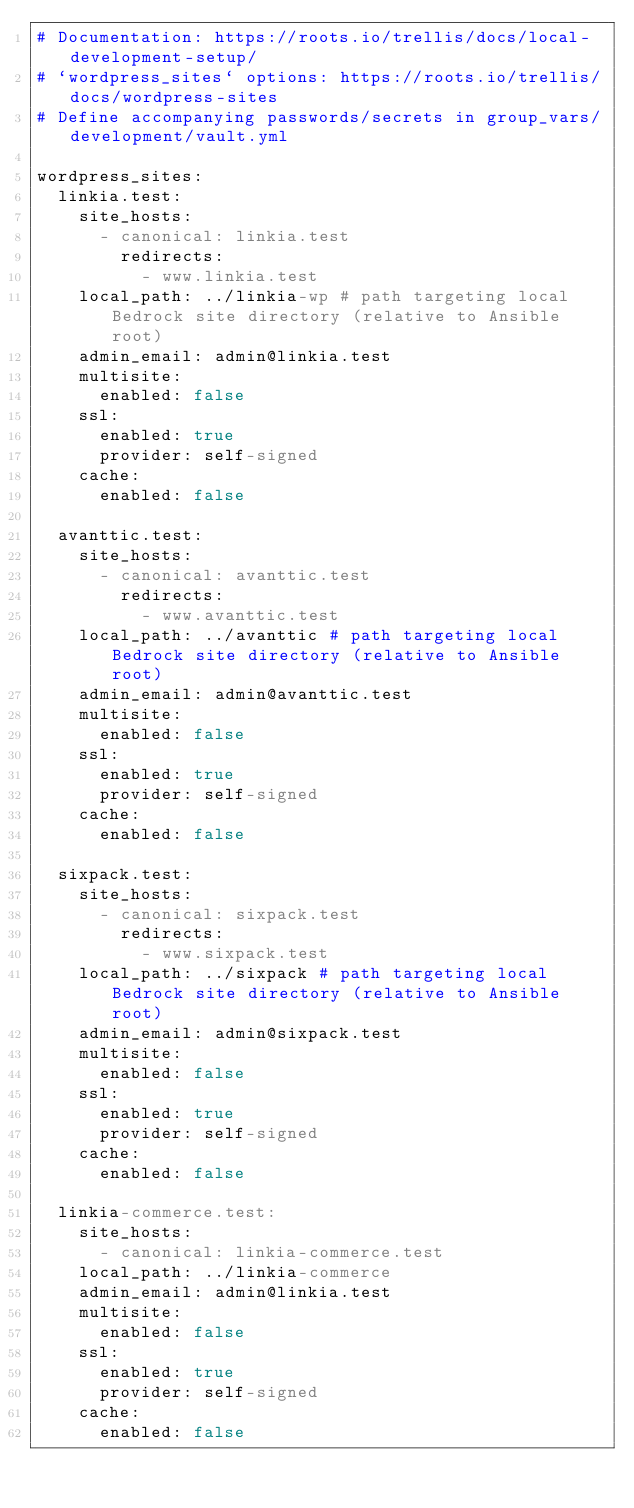Convert code to text. <code><loc_0><loc_0><loc_500><loc_500><_YAML_># Documentation: https://roots.io/trellis/docs/local-development-setup/
# `wordpress_sites` options: https://roots.io/trellis/docs/wordpress-sites
# Define accompanying passwords/secrets in group_vars/development/vault.yml

wordpress_sites:
  linkia.test:
    site_hosts:
      - canonical: linkia.test
        redirects:
          - www.linkia.test
    local_path: ../linkia-wp # path targeting local Bedrock site directory (relative to Ansible root)
    admin_email: admin@linkia.test
    multisite:
      enabled: false
    ssl:
      enabled: true
      provider: self-signed
    cache:
      enabled: false

  avanttic.test:
    site_hosts:
      - canonical: avanttic.test
        redirects:
          - www.avanttic.test
    local_path: ../avanttic # path targeting local Bedrock site directory (relative to Ansible root)
    admin_email: admin@avanttic.test
    multisite:
      enabled: false
    ssl:
      enabled: true
      provider: self-signed
    cache:
      enabled: false

  sixpack.test:
    site_hosts:
      - canonical: sixpack.test
        redirects:
          - www.sixpack.test
    local_path: ../sixpack # path targeting local Bedrock site directory (relative to Ansible root)
    admin_email: admin@sixpack.test
    multisite:
      enabled: false
    ssl:
      enabled: true
      provider: self-signed
    cache:
      enabled: false

  linkia-commerce.test:
    site_hosts:
      - canonical: linkia-commerce.test
    local_path: ../linkia-commerce
    admin_email: admin@linkia.test
    multisite:
      enabled: false
    ssl:
      enabled: true
      provider: self-signed
    cache:
      enabled: false
</code> 